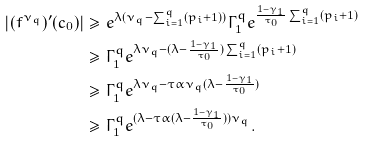Convert formula to latex. <formula><loc_0><loc_0><loc_500><loc_500>| ( f ^ { \nu _ { q } } ) ^ { \prime } ( c _ { 0 } ) | & \geq e ^ { \lambda ( \nu _ { q } - \sum _ { i = 1 } ^ { q } ( p _ { i } + 1 ) ) } \Gamma _ { 1 } ^ { q } e ^ { \frac { 1 - \gamma _ { 1 } } { \tau _ { 0 } } \sum _ { i = 1 } ^ { q } ( p _ { i } + 1 ) } \\ & \geq \Gamma _ { 1 } ^ { q } e ^ { \lambda \nu _ { q } - ( \lambda - \frac { 1 - \gamma _ { 1 } } { \tau _ { 0 } } ) \sum _ { i = 1 } ^ { q } ( p _ { i } + 1 ) } \\ & \geq \Gamma _ { 1 } ^ { q } e ^ { \lambda \nu _ { q } - \tau \alpha \nu _ { q } ( \lambda - \frac { 1 - \gamma _ { 1 } } { \tau _ { 0 } } ) } \\ & \geq \Gamma _ { 1 } ^ { q } e ^ { ( \lambda - \tau \alpha ( \lambda - \frac { 1 - \gamma _ { 1 } } { \tau _ { 0 } } ) ) \nu _ { q } } .</formula> 